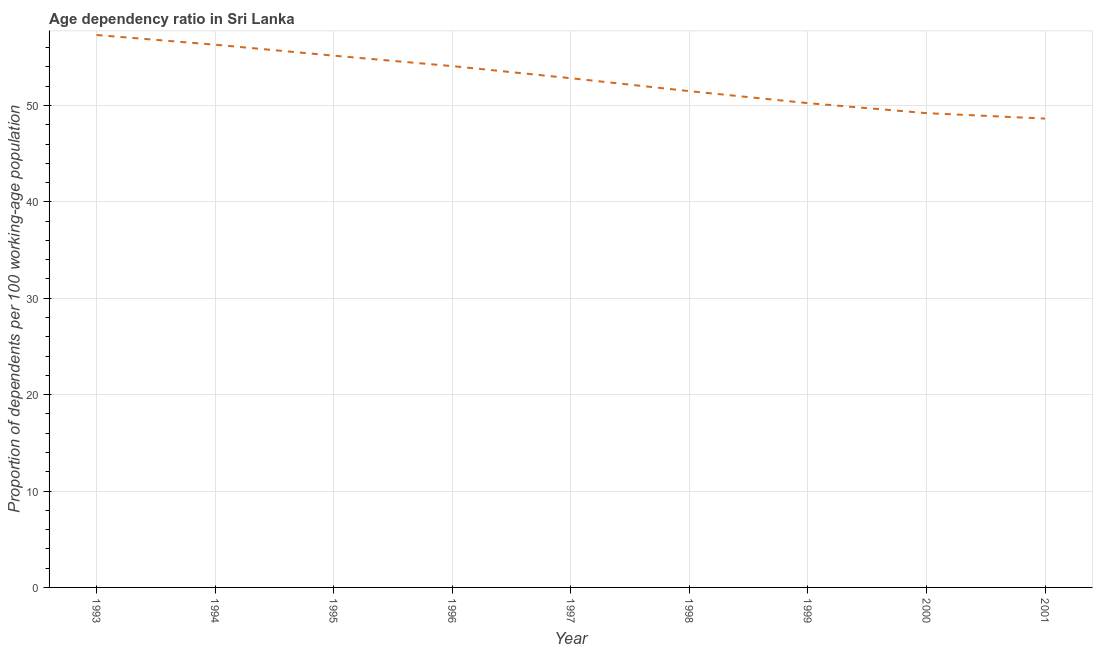What is the age dependency ratio in 2001?
Your answer should be very brief. 48.64. Across all years, what is the maximum age dependency ratio?
Give a very brief answer. 57.31. Across all years, what is the minimum age dependency ratio?
Make the answer very short. 48.64. In which year was the age dependency ratio minimum?
Provide a succinct answer. 2001. What is the sum of the age dependency ratio?
Offer a terse response. 475.29. What is the difference between the age dependency ratio in 1999 and 2001?
Your answer should be very brief. 1.6. What is the average age dependency ratio per year?
Ensure brevity in your answer.  52.81. What is the median age dependency ratio?
Make the answer very short. 52.83. In how many years, is the age dependency ratio greater than 28 ?
Your answer should be compact. 9. What is the ratio of the age dependency ratio in 1995 to that in 1996?
Your answer should be compact. 1.02. What is the difference between the highest and the second highest age dependency ratio?
Offer a terse response. 1.01. Is the sum of the age dependency ratio in 1993 and 2001 greater than the maximum age dependency ratio across all years?
Make the answer very short. Yes. What is the difference between the highest and the lowest age dependency ratio?
Your response must be concise. 8.67. In how many years, is the age dependency ratio greater than the average age dependency ratio taken over all years?
Make the answer very short. 5. How many lines are there?
Offer a very short reply. 1. How many years are there in the graph?
Make the answer very short. 9. Are the values on the major ticks of Y-axis written in scientific E-notation?
Provide a short and direct response. No. Does the graph contain grids?
Offer a very short reply. Yes. What is the title of the graph?
Your answer should be very brief. Age dependency ratio in Sri Lanka. What is the label or title of the X-axis?
Provide a short and direct response. Year. What is the label or title of the Y-axis?
Provide a succinct answer. Proportion of dependents per 100 working-age population. What is the Proportion of dependents per 100 working-age population in 1993?
Ensure brevity in your answer.  57.31. What is the Proportion of dependents per 100 working-age population of 1994?
Give a very brief answer. 56.31. What is the Proportion of dependents per 100 working-age population in 1995?
Keep it short and to the point. 55.17. What is the Proportion of dependents per 100 working-age population in 1996?
Your answer should be very brief. 54.09. What is the Proportion of dependents per 100 working-age population in 1997?
Provide a short and direct response. 52.83. What is the Proportion of dependents per 100 working-age population in 1998?
Keep it short and to the point. 51.49. What is the Proportion of dependents per 100 working-age population of 1999?
Your answer should be compact. 50.24. What is the Proportion of dependents per 100 working-age population in 2000?
Provide a short and direct response. 49.21. What is the Proportion of dependents per 100 working-age population in 2001?
Offer a terse response. 48.64. What is the difference between the Proportion of dependents per 100 working-age population in 1993 and 1994?
Provide a succinct answer. 1.01. What is the difference between the Proportion of dependents per 100 working-age population in 1993 and 1995?
Keep it short and to the point. 2.14. What is the difference between the Proportion of dependents per 100 working-age population in 1993 and 1996?
Your response must be concise. 3.23. What is the difference between the Proportion of dependents per 100 working-age population in 1993 and 1997?
Your answer should be compact. 4.48. What is the difference between the Proportion of dependents per 100 working-age population in 1993 and 1998?
Your answer should be very brief. 5.82. What is the difference between the Proportion of dependents per 100 working-age population in 1993 and 1999?
Your answer should be compact. 7.07. What is the difference between the Proportion of dependents per 100 working-age population in 1993 and 2000?
Give a very brief answer. 8.11. What is the difference between the Proportion of dependents per 100 working-age population in 1993 and 2001?
Make the answer very short. 8.67. What is the difference between the Proportion of dependents per 100 working-age population in 1994 and 1995?
Ensure brevity in your answer.  1.14. What is the difference between the Proportion of dependents per 100 working-age population in 1994 and 1996?
Your answer should be very brief. 2.22. What is the difference between the Proportion of dependents per 100 working-age population in 1994 and 1997?
Give a very brief answer. 3.48. What is the difference between the Proportion of dependents per 100 working-age population in 1994 and 1998?
Your response must be concise. 4.82. What is the difference between the Proportion of dependents per 100 working-age population in 1994 and 1999?
Your response must be concise. 6.06. What is the difference between the Proportion of dependents per 100 working-age population in 1994 and 2000?
Your answer should be very brief. 7.1. What is the difference between the Proportion of dependents per 100 working-age population in 1994 and 2001?
Provide a short and direct response. 7.67. What is the difference between the Proportion of dependents per 100 working-age population in 1995 and 1996?
Make the answer very short. 1.08. What is the difference between the Proportion of dependents per 100 working-age population in 1995 and 1997?
Offer a very short reply. 2.34. What is the difference between the Proportion of dependents per 100 working-age population in 1995 and 1998?
Offer a very short reply. 3.68. What is the difference between the Proportion of dependents per 100 working-age population in 1995 and 1999?
Your answer should be compact. 4.93. What is the difference between the Proportion of dependents per 100 working-age population in 1995 and 2000?
Your response must be concise. 5.96. What is the difference between the Proportion of dependents per 100 working-age population in 1995 and 2001?
Give a very brief answer. 6.53. What is the difference between the Proportion of dependents per 100 working-age population in 1996 and 1997?
Offer a very short reply. 1.26. What is the difference between the Proportion of dependents per 100 working-age population in 1996 and 1998?
Offer a terse response. 2.6. What is the difference between the Proportion of dependents per 100 working-age population in 1996 and 1999?
Ensure brevity in your answer.  3.84. What is the difference between the Proportion of dependents per 100 working-age population in 1996 and 2000?
Make the answer very short. 4.88. What is the difference between the Proportion of dependents per 100 working-age population in 1996 and 2001?
Keep it short and to the point. 5.44. What is the difference between the Proportion of dependents per 100 working-age population in 1997 and 1998?
Keep it short and to the point. 1.34. What is the difference between the Proportion of dependents per 100 working-age population in 1997 and 1999?
Provide a short and direct response. 2.59. What is the difference between the Proportion of dependents per 100 working-age population in 1997 and 2000?
Your answer should be compact. 3.62. What is the difference between the Proportion of dependents per 100 working-age population in 1997 and 2001?
Your response must be concise. 4.19. What is the difference between the Proportion of dependents per 100 working-age population in 1998 and 1999?
Provide a succinct answer. 1.25. What is the difference between the Proportion of dependents per 100 working-age population in 1998 and 2000?
Your answer should be compact. 2.28. What is the difference between the Proportion of dependents per 100 working-age population in 1998 and 2001?
Give a very brief answer. 2.85. What is the difference between the Proportion of dependents per 100 working-age population in 1999 and 2000?
Your answer should be very brief. 1.04. What is the difference between the Proportion of dependents per 100 working-age population in 1999 and 2001?
Your answer should be very brief. 1.6. What is the difference between the Proportion of dependents per 100 working-age population in 2000 and 2001?
Ensure brevity in your answer.  0.56. What is the ratio of the Proportion of dependents per 100 working-age population in 1993 to that in 1994?
Ensure brevity in your answer.  1.02. What is the ratio of the Proportion of dependents per 100 working-age population in 1993 to that in 1995?
Your answer should be very brief. 1.04. What is the ratio of the Proportion of dependents per 100 working-age population in 1993 to that in 1996?
Keep it short and to the point. 1.06. What is the ratio of the Proportion of dependents per 100 working-age population in 1993 to that in 1997?
Provide a short and direct response. 1.08. What is the ratio of the Proportion of dependents per 100 working-age population in 1993 to that in 1998?
Keep it short and to the point. 1.11. What is the ratio of the Proportion of dependents per 100 working-age population in 1993 to that in 1999?
Make the answer very short. 1.14. What is the ratio of the Proportion of dependents per 100 working-age population in 1993 to that in 2000?
Ensure brevity in your answer.  1.17. What is the ratio of the Proportion of dependents per 100 working-age population in 1993 to that in 2001?
Offer a very short reply. 1.18. What is the ratio of the Proportion of dependents per 100 working-age population in 1994 to that in 1996?
Provide a succinct answer. 1.04. What is the ratio of the Proportion of dependents per 100 working-age population in 1994 to that in 1997?
Offer a terse response. 1.07. What is the ratio of the Proportion of dependents per 100 working-age population in 1994 to that in 1998?
Make the answer very short. 1.09. What is the ratio of the Proportion of dependents per 100 working-age population in 1994 to that in 1999?
Keep it short and to the point. 1.12. What is the ratio of the Proportion of dependents per 100 working-age population in 1994 to that in 2000?
Your response must be concise. 1.14. What is the ratio of the Proportion of dependents per 100 working-age population in 1994 to that in 2001?
Your answer should be compact. 1.16. What is the ratio of the Proportion of dependents per 100 working-age population in 1995 to that in 1996?
Give a very brief answer. 1.02. What is the ratio of the Proportion of dependents per 100 working-age population in 1995 to that in 1997?
Provide a short and direct response. 1.04. What is the ratio of the Proportion of dependents per 100 working-age population in 1995 to that in 1998?
Offer a very short reply. 1.07. What is the ratio of the Proportion of dependents per 100 working-age population in 1995 to that in 1999?
Make the answer very short. 1.1. What is the ratio of the Proportion of dependents per 100 working-age population in 1995 to that in 2000?
Offer a terse response. 1.12. What is the ratio of the Proportion of dependents per 100 working-age population in 1995 to that in 2001?
Make the answer very short. 1.13. What is the ratio of the Proportion of dependents per 100 working-age population in 1996 to that in 1998?
Make the answer very short. 1.05. What is the ratio of the Proportion of dependents per 100 working-age population in 1996 to that in 1999?
Keep it short and to the point. 1.08. What is the ratio of the Proportion of dependents per 100 working-age population in 1996 to that in 2000?
Make the answer very short. 1.1. What is the ratio of the Proportion of dependents per 100 working-age population in 1996 to that in 2001?
Provide a short and direct response. 1.11. What is the ratio of the Proportion of dependents per 100 working-age population in 1997 to that in 1998?
Ensure brevity in your answer.  1.03. What is the ratio of the Proportion of dependents per 100 working-age population in 1997 to that in 1999?
Provide a short and direct response. 1.05. What is the ratio of the Proportion of dependents per 100 working-age population in 1997 to that in 2000?
Make the answer very short. 1.07. What is the ratio of the Proportion of dependents per 100 working-age population in 1997 to that in 2001?
Your answer should be very brief. 1.09. What is the ratio of the Proportion of dependents per 100 working-age population in 1998 to that in 1999?
Offer a very short reply. 1.02. What is the ratio of the Proportion of dependents per 100 working-age population in 1998 to that in 2000?
Offer a very short reply. 1.05. What is the ratio of the Proportion of dependents per 100 working-age population in 1998 to that in 2001?
Keep it short and to the point. 1.06. What is the ratio of the Proportion of dependents per 100 working-age population in 1999 to that in 2000?
Ensure brevity in your answer.  1.02. What is the ratio of the Proportion of dependents per 100 working-age population in 1999 to that in 2001?
Make the answer very short. 1.03. 